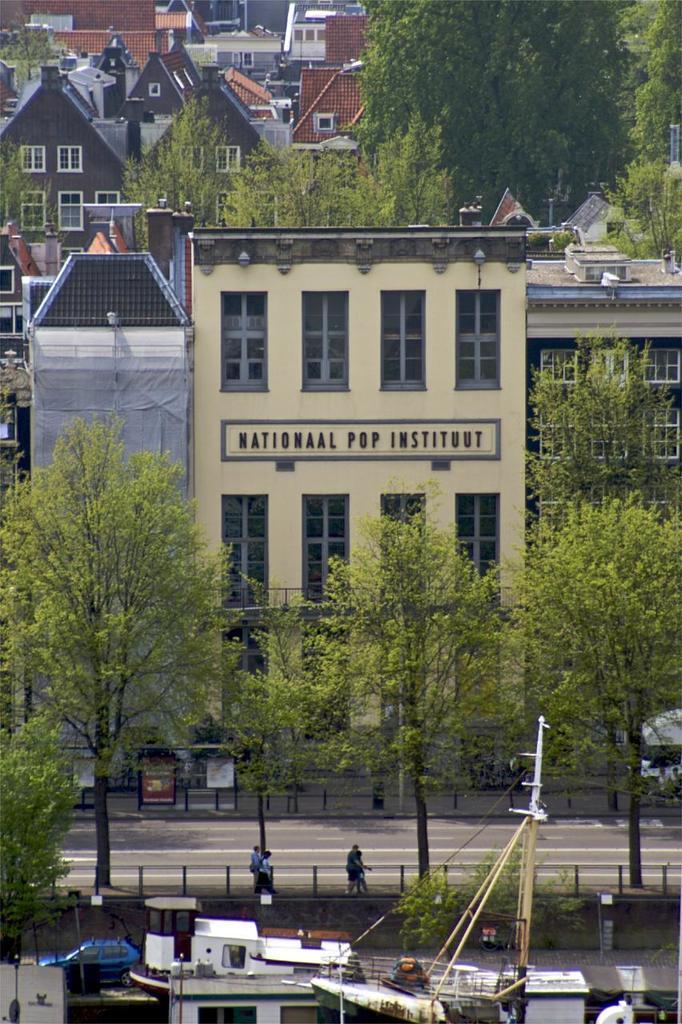Describe this image in one or two sentences. In this image there are buildings and trees. In front of the buildings there is a metal rod fence for the pavement, on the pavement there are a few pedestrians walking and there are bus shelters and vehicles on the roads. In front of the image there are boats. 